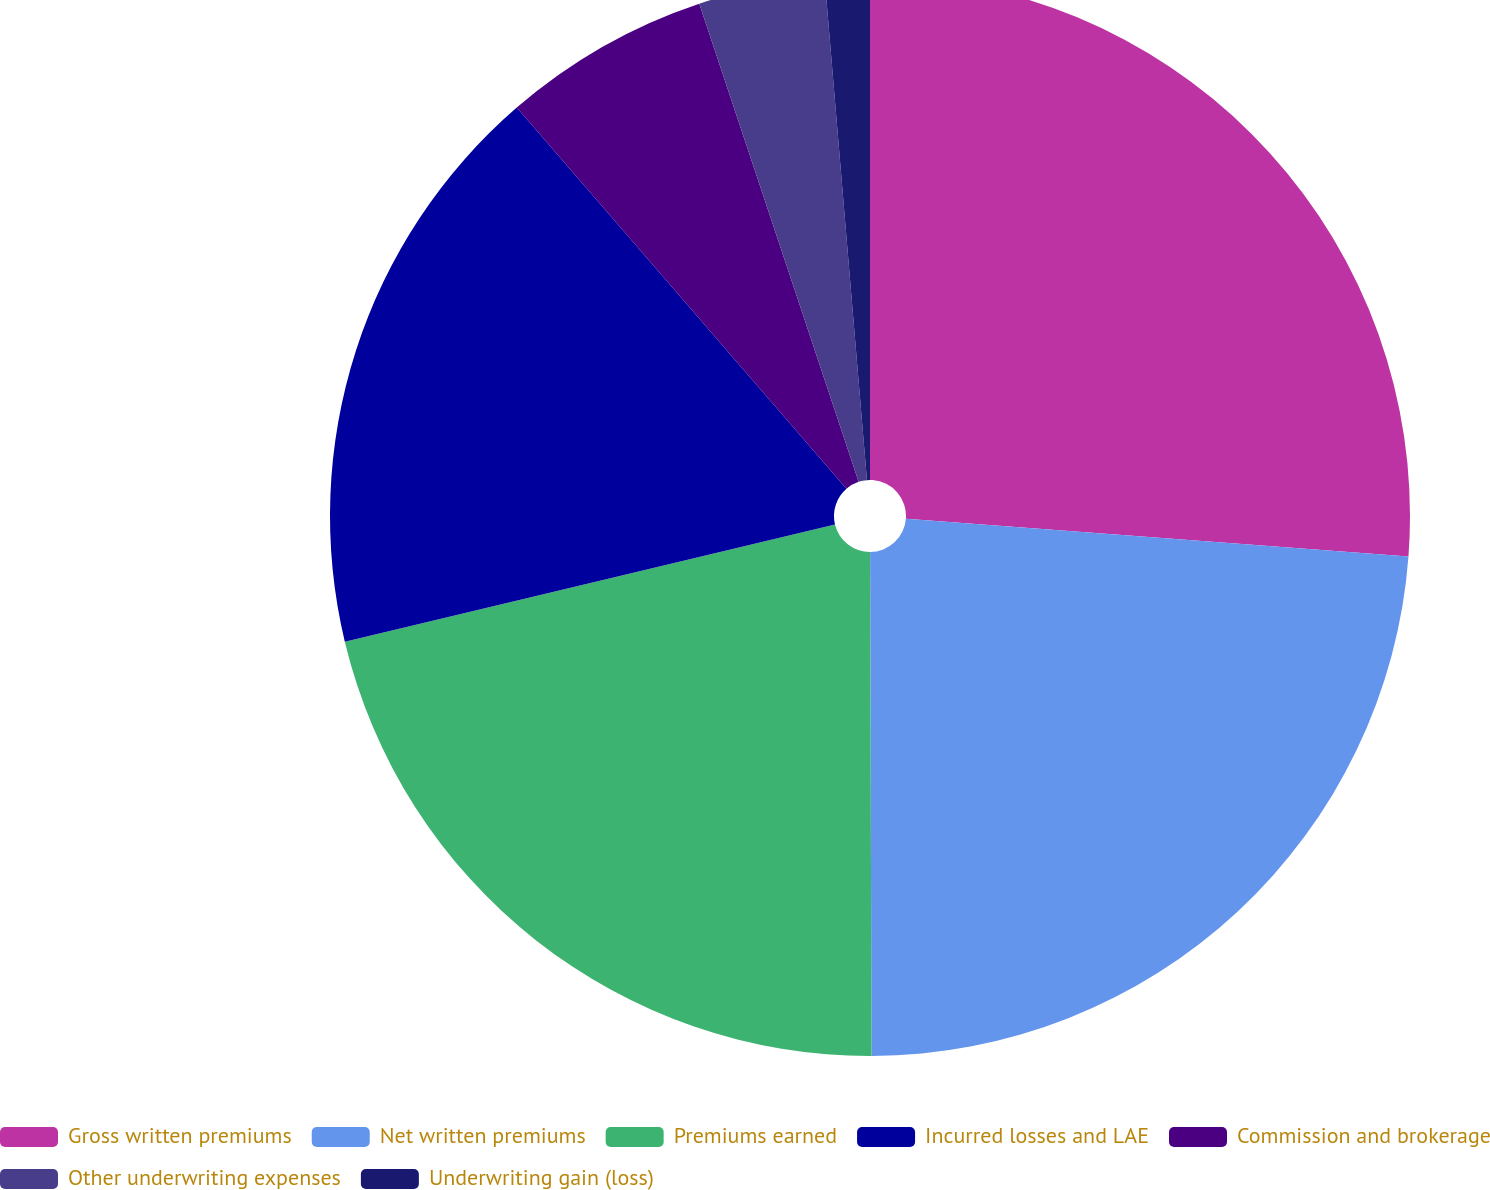Convert chart to OTSL. <chart><loc_0><loc_0><loc_500><loc_500><pie_chart><fcel>Gross written premiums<fcel>Net written premiums<fcel>Premiums earned<fcel>Incurred losses and LAE<fcel>Commission and brokerage<fcel>Other underwriting expenses<fcel>Underwriting gain (loss)<nl><fcel>26.2%<fcel>23.76%<fcel>21.31%<fcel>17.39%<fcel>6.23%<fcel>3.78%<fcel>1.34%<nl></chart> 